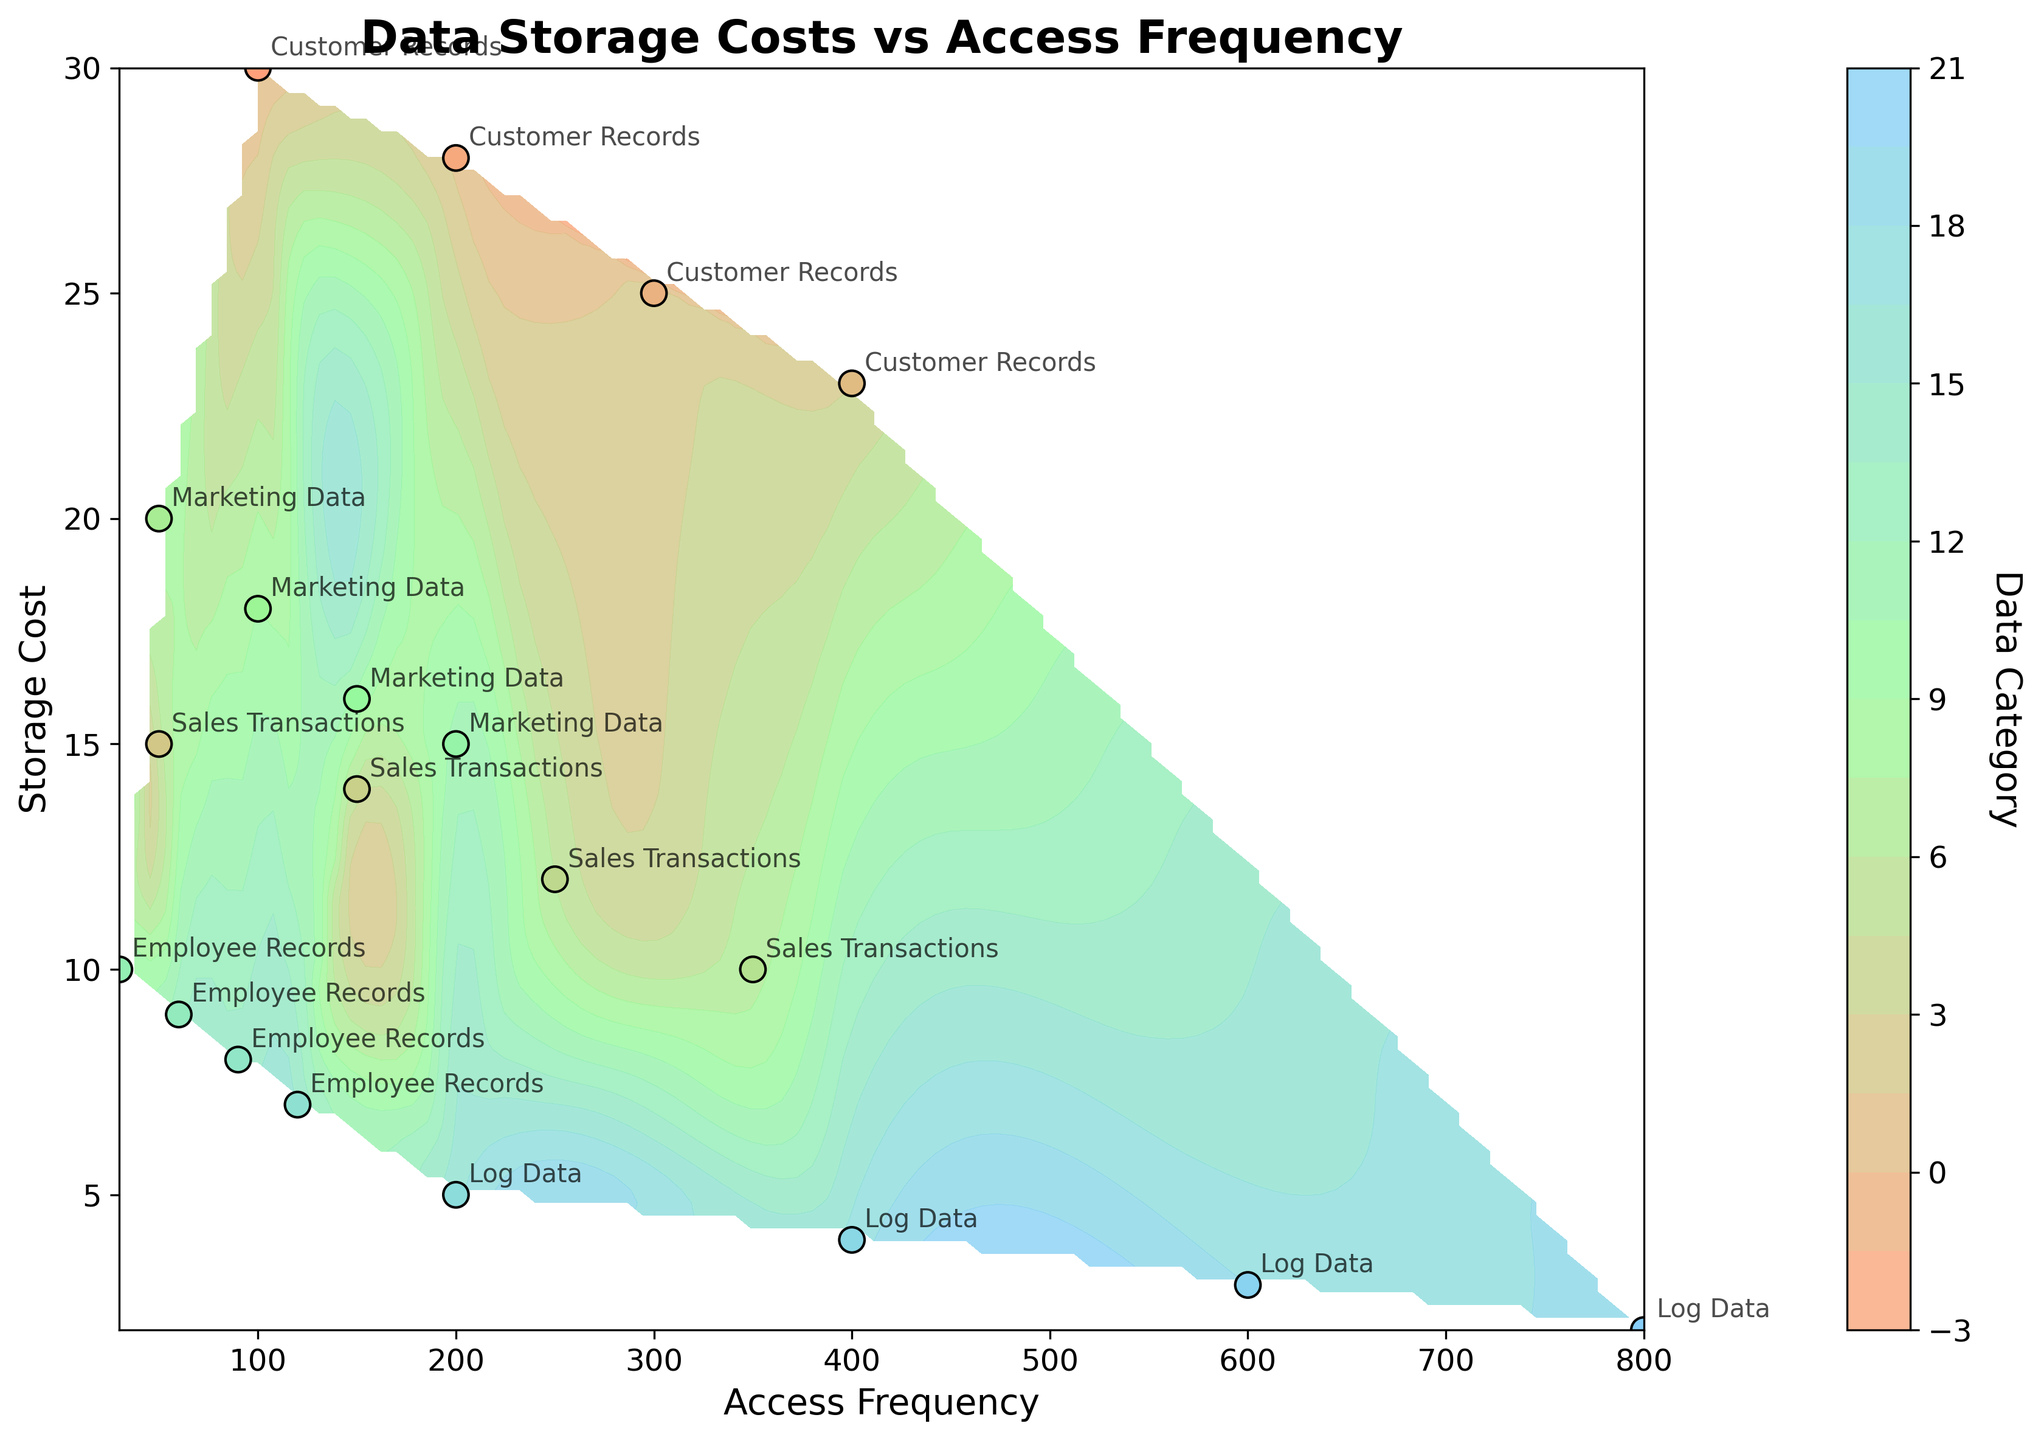What's the title of the figure? The title is located at the top of the figure and is written in a larger, bold font for easy identification.
Answer: Data Storage Costs vs Access Frequency How many data categories are shown in the figure? Count all the unique labels present for the data points in the scatter plot. These labels are annotated next to each data point.
Answer: 5 At what Access Frequency is the Storage Cost for Sales Transactions the lowest? Locate the points labeled as "Sales Transactions" on the scatter plot and find the one with the lowest Storage Cost value on the vertical axis.
Answer: 350 Which category has the highest storage cost at an Access Frequency of 200? Identify the point with an Access Frequency of 200, then look for the highest Storage Cost value among these points.
Answer: Customer Records What's the general trend between data storage cost and access frequency? Observe the overall pattern of the data points and contour lines. Determine whether Storage Cost increases or decreases as Access Frequency increases.
Answer: Storage Cost generally decreases as Access Frequency increases Which data category has the steepest drop in storage cost as the access frequency increases? Compare the changes in storage cost against access frequency for each category by observing the separation between points of the same category along the vertical axis.
Answer: Customer Records Which data category has the most evenly spaced points in terms of access frequency? Look for the data points aligned horizontally that are most evenly spaced along the Access Frequency axis and labeled with the same category.
Answer: Log Data What is the average storage cost for Employee Records at access frequencies of 30, 60, and 90? Locate the points labeled as "Employee Records" and having access frequencies of 30, 60, and 90. Average their Storage Cost values: (10 + 9 + 8)/3.
Answer: 9 Between Customer Records and Marketing Data, which category has a higher storage cost for an access frequency of 100? Compare the Storage Cost for points labeled "Customer Records" and "Marketing Data" that have an access frequency of 100.
Answer: Customer Records Which data category achieves the lowest storage cost at any access frequency? Observe all the data points and identify the one with the lowest Storage Cost, then note the corresponding data category.
Answer: Log Data 